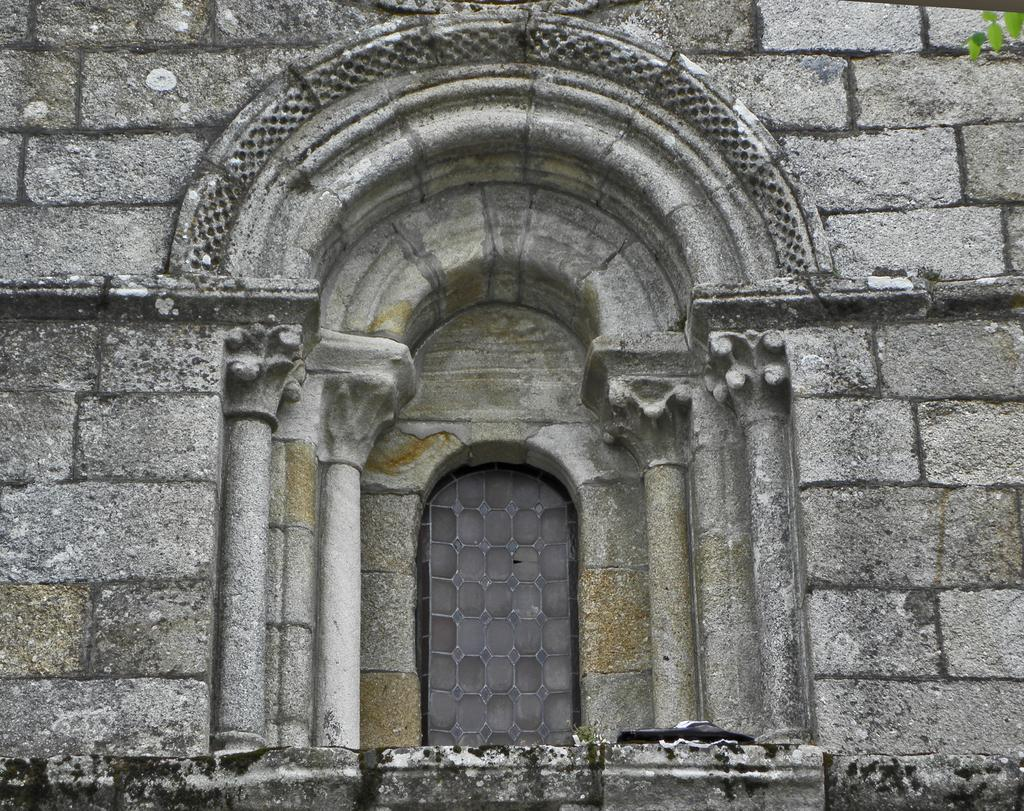What is the main structure visible in the image? There is a wall in the image. Can you describe any specific features of the wall? There is a window in the center of the wall. What can be seen in the top right corner of the image? There are leaves visible in the top right corner of the image. What type of steam is coming out of the thing in the image? There is no steam or thing present in the image. 